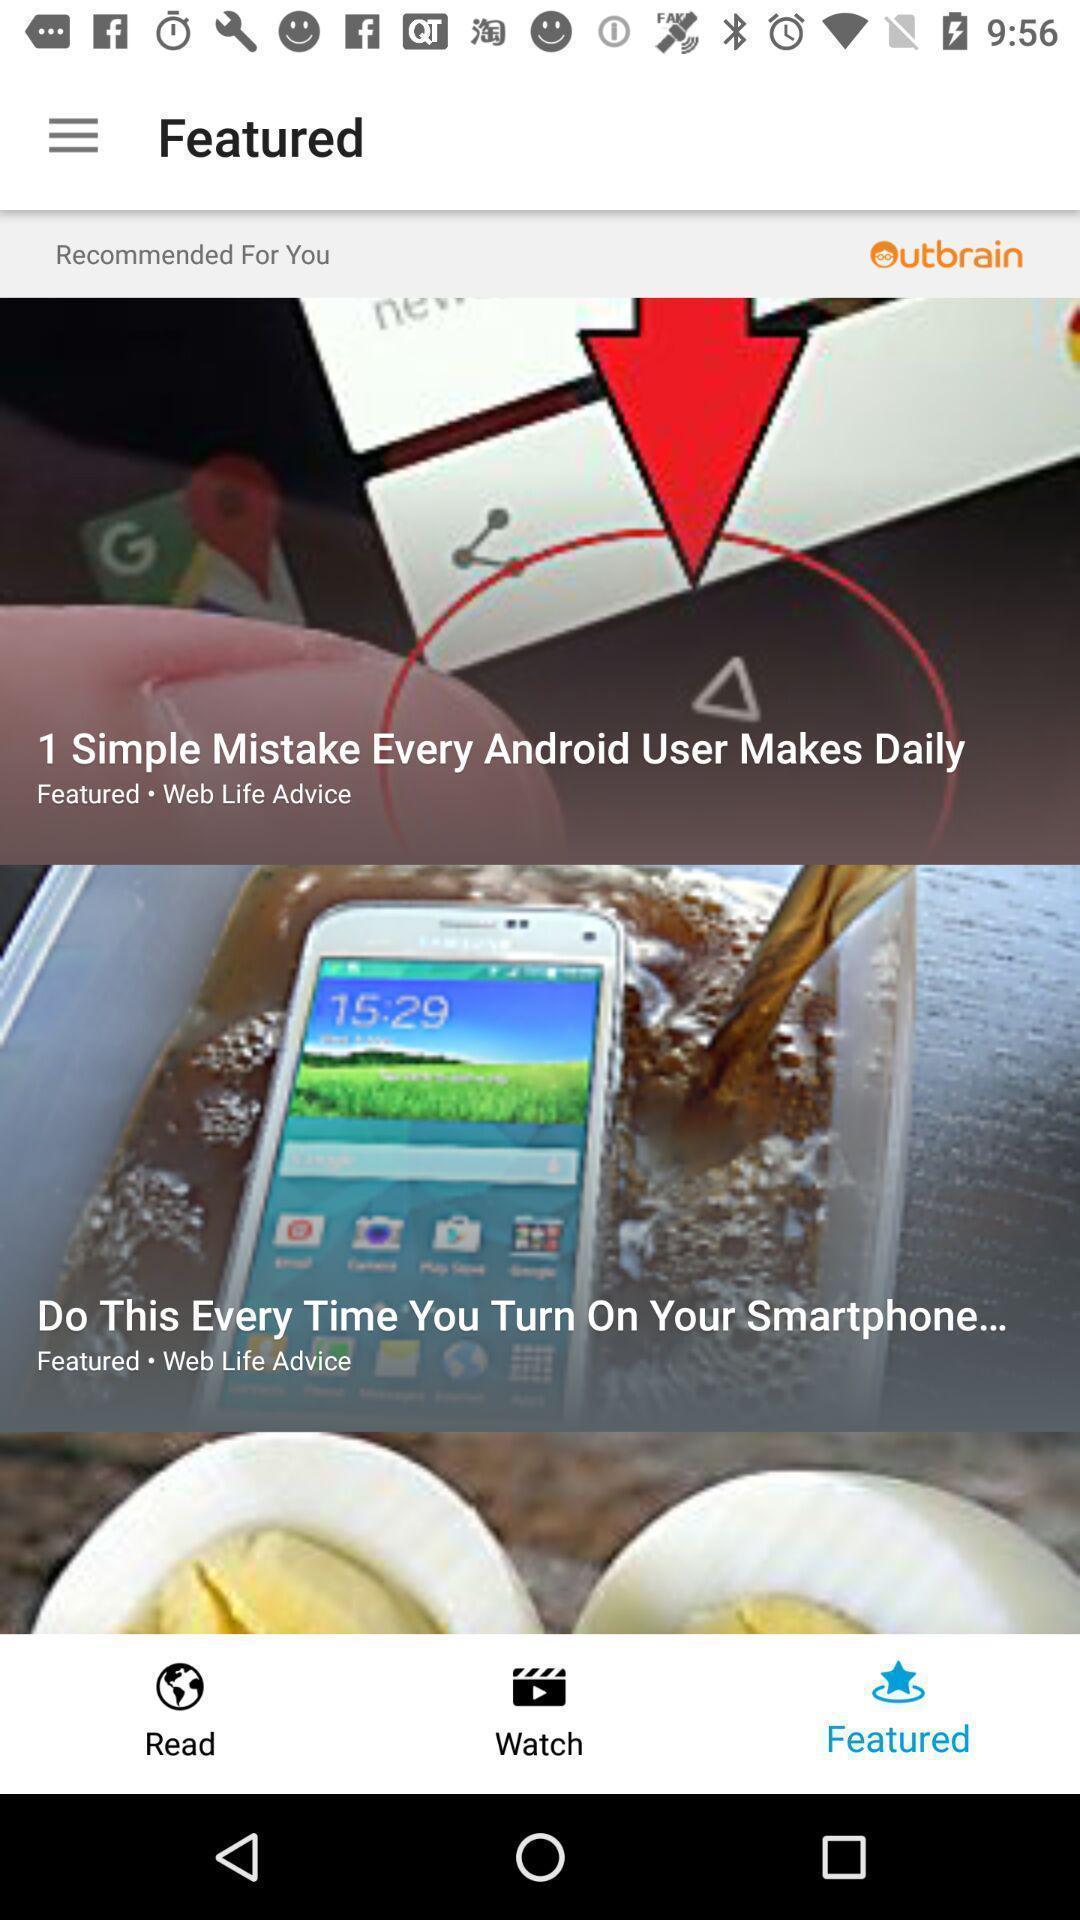What is the overall content of this screenshot? Various feed displayed. 